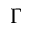Convert formula to latex. <formula><loc_0><loc_0><loc_500><loc_500>\Gamma</formula> 